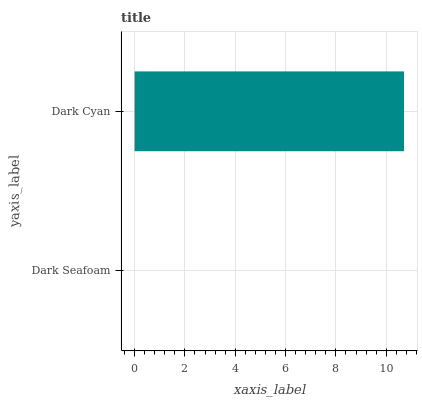Is Dark Seafoam the minimum?
Answer yes or no. Yes. Is Dark Cyan the maximum?
Answer yes or no. Yes. Is Dark Cyan the minimum?
Answer yes or no. No. Is Dark Cyan greater than Dark Seafoam?
Answer yes or no. Yes. Is Dark Seafoam less than Dark Cyan?
Answer yes or no. Yes. Is Dark Seafoam greater than Dark Cyan?
Answer yes or no. No. Is Dark Cyan less than Dark Seafoam?
Answer yes or no. No. Is Dark Cyan the high median?
Answer yes or no. Yes. Is Dark Seafoam the low median?
Answer yes or no. Yes. Is Dark Seafoam the high median?
Answer yes or no. No. Is Dark Cyan the low median?
Answer yes or no. No. 